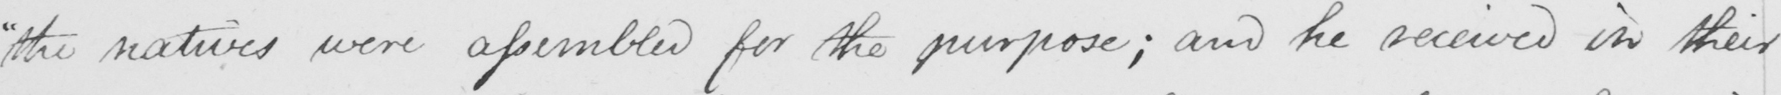Can you read and transcribe this handwriting? " the natives were assembled for the purpose ; and he received in their 